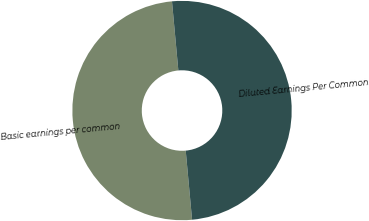Convert chart to OTSL. <chart><loc_0><loc_0><loc_500><loc_500><pie_chart><fcel>Basic earnings per common<fcel>Diluted Earnings Per Common<nl><fcel>50.0%<fcel>50.0%<nl></chart> 